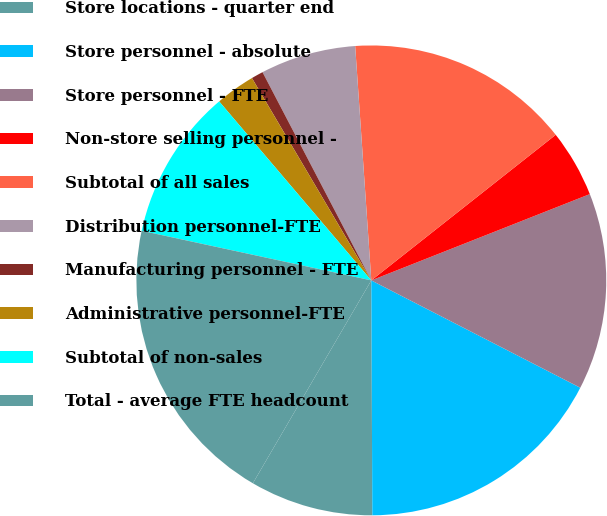Convert chart. <chart><loc_0><loc_0><loc_500><loc_500><pie_chart><fcel>Store locations - quarter end<fcel>Store personnel - absolute<fcel>Store personnel - FTE<fcel>Non-store selling personnel -<fcel>Subtotal of all sales<fcel>Distribution personnel-FTE<fcel>Manufacturing personnel - FTE<fcel>Administrative personnel-FTE<fcel>Subtotal of non-sales<fcel>Total - average FTE headcount<nl><fcel>8.48%<fcel>17.38%<fcel>13.54%<fcel>4.65%<fcel>15.46%<fcel>6.57%<fcel>0.82%<fcel>2.73%<fcel>10.4%<fcel>19.98%<nl></chart> 